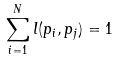Convert formula to latex. <formula><loc_0><loc_0><loc_500><loc_500>\sum _ { i = 1 } ^ { N } l ( p _ { i } , p _ { j } ) = 1</formula> 